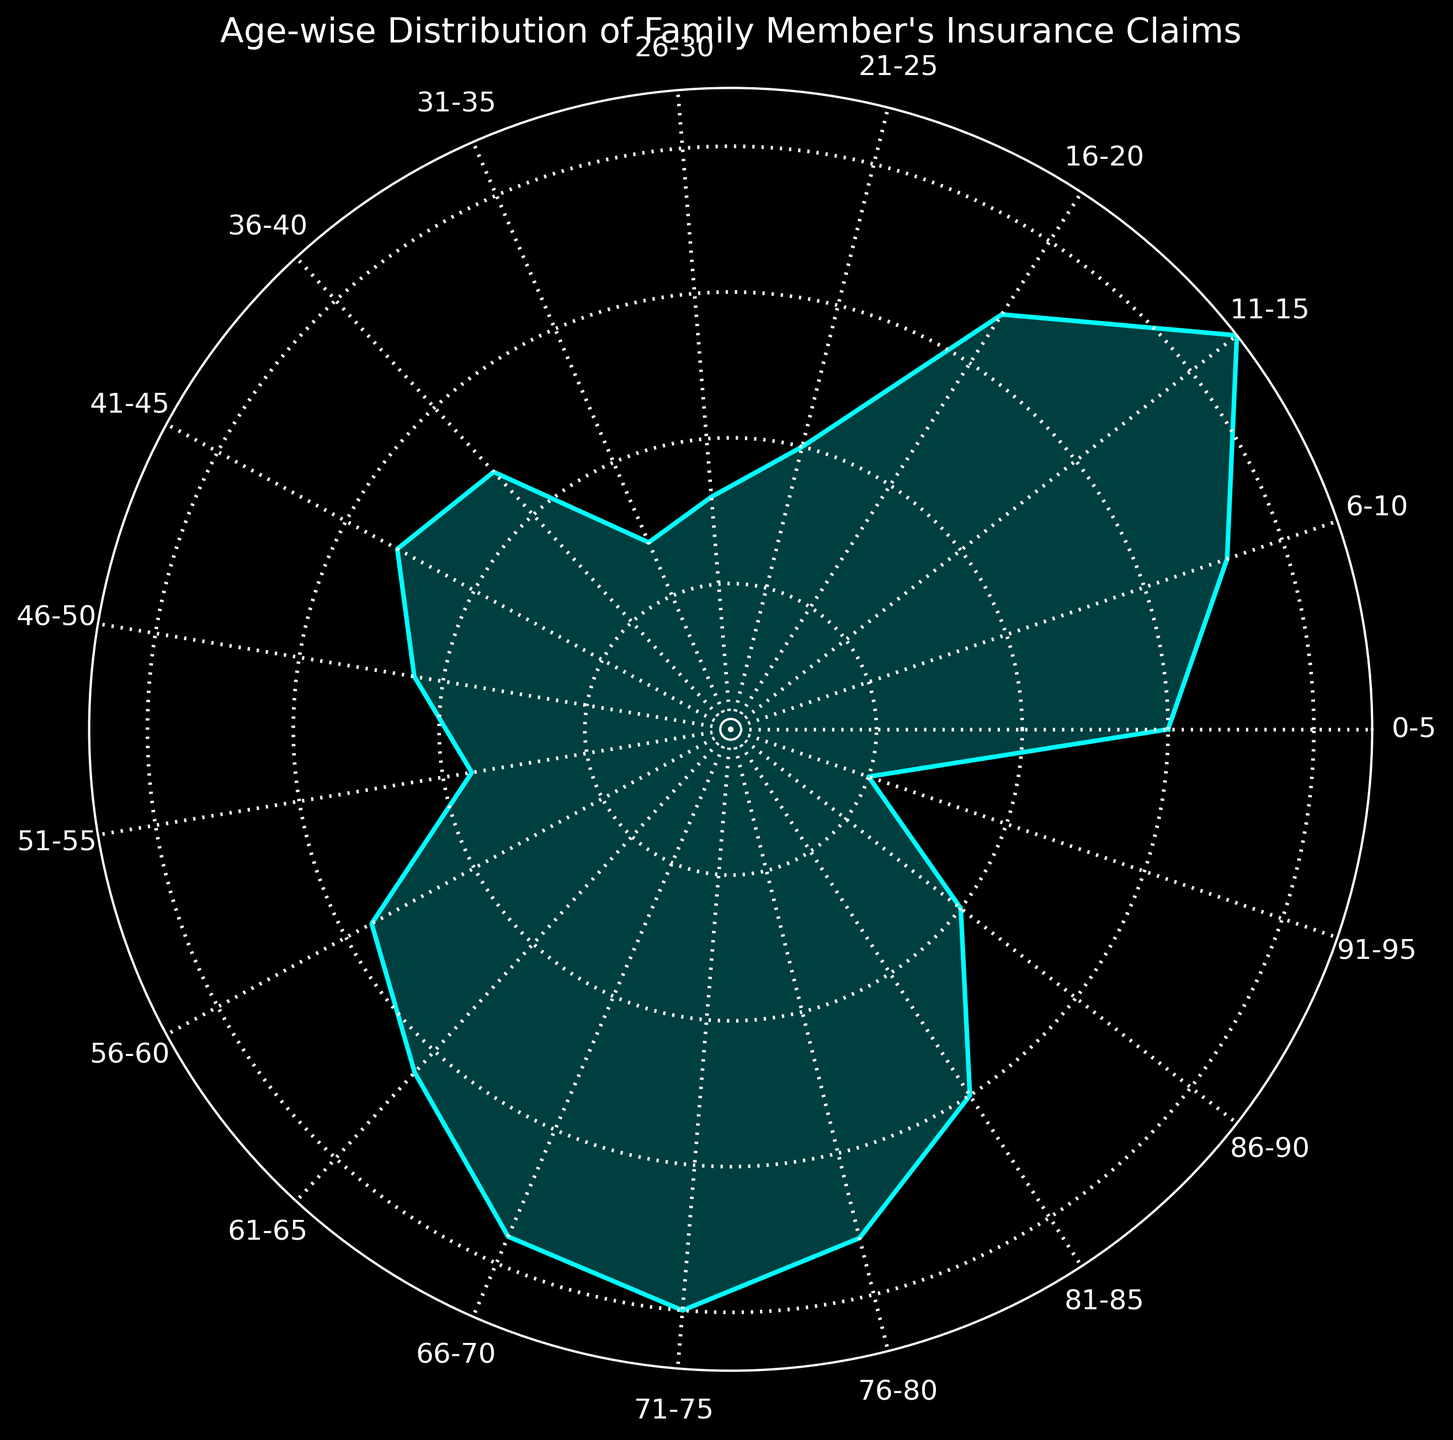Which age group has the highest number of insurance claims? The age group with the highest number of insurance claims is represented by the longest segment in the rose chart. From the figure, it is the group with the largest radius.
Answer: 11-15 What is the total number of claims for age groups 66-70 and 71-75 combined? To find the total, add the number of claims for the two age groups 66-70 and 71-75. This is represented by summing their respective lengths in the chart: 19 + 20 = 39.
Answer: 39 Which age group has fewer claims: 21-25 or 31-35? To determine which group has fewer claims, compare the lengths of the segments for age groups 21-25 and 31-35. The length for 31-35 is shorter than 21-25 in the rose chart.
Answer: 31-35 What is the average number of claims for the age groups 0-5, 6-10, and 11-15? Calculate the average by summing the number of claims for 0-5, 6-10, and 11-15, then dividing by 3: (15 + 18 + 22) / 3 = 55 / 3 ≈ 18.33.
Answer: 18.33 How does the number of claims for the age group 86-90 compare to the age group 61-65? Compare the lengths of the segments for age groups 86-90 and 61-65. The segment for 86-90 is shorter than that of 61-65.
Answer: Fewer Which age groups have exactly 15 claims? Identify the age groups with segments that are equal in length to 15 claims. The rose chart shows that these are the groups 0-5 and 81-85.
Answer: 0-5, 81-85 Sum the claims for the age groups 76-80, 26-30, and 91-95. Add the number of claims for age groups 76-80, 26-30, and 91-95: 18 + 8 + 5 = 31.
Answer: 31 Between 46-50 and 51-55, which age group has more insurance claims? Compare the lengths of the segments for age groups 46-50 and 51-55 in the rose chart. 46-50 has a longer segment.
Answer: 46-50 